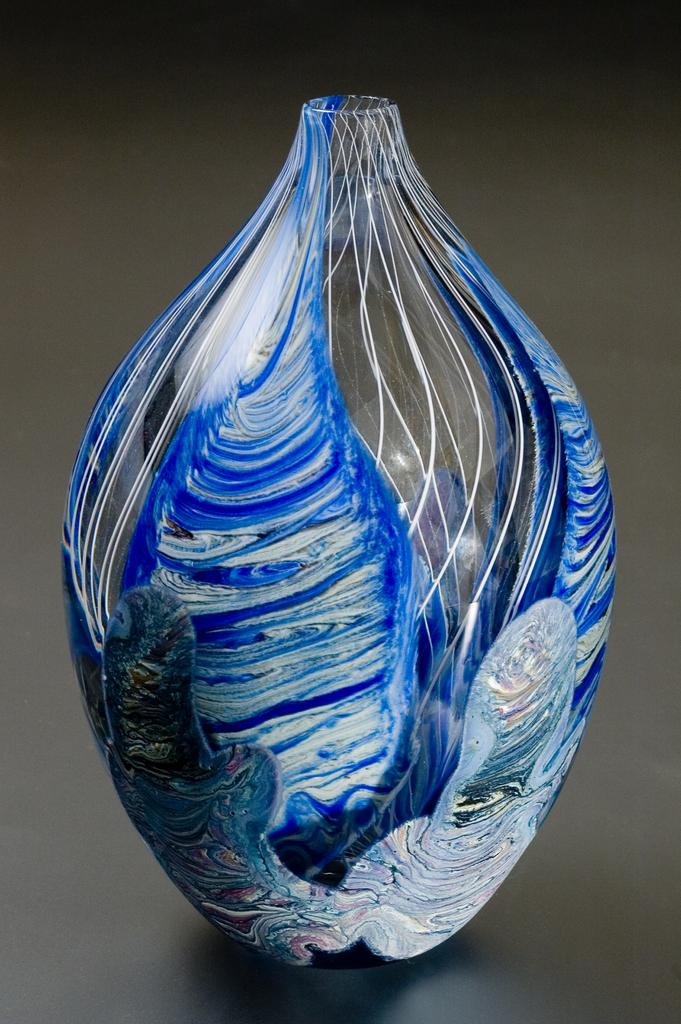What object can be seen in the image? There is a vase in the image. What is unique about the vase? The vase has a painting on it. How does the vase help the person in the image sleep better? The image does not show a person or any indication of sleep, so it is not possible to determine how the vase might affect someone's sleep. 